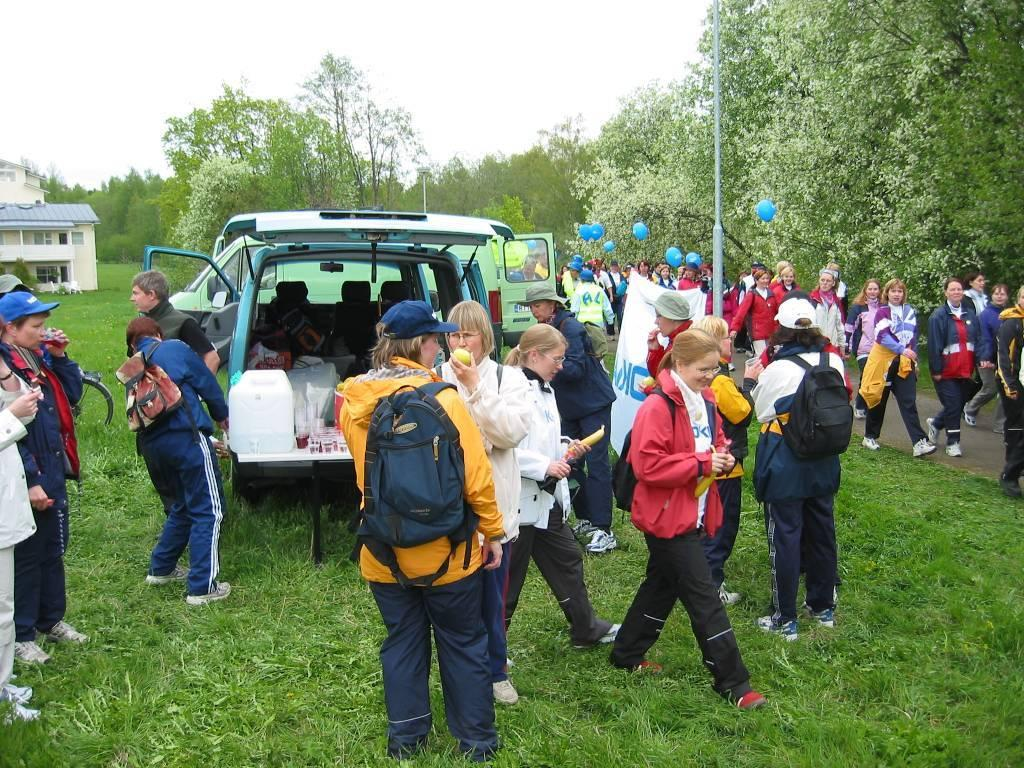What type of motor vehicle is on the ground in the image? The image does not specify the type of motor vehicle, but there is a motor vehicle on the ground. What is the person standing on in the image? The person is standing on the ground in the image. What can be seen on the ground in the image? There is a road in the image. What is visible in the background of the image? There are poles, buildings, trees, and the sky visible in the background of the image. Can you hear the person crying in the image? There is no indication of sound or crying in the image, as it is a still photograph. What type of ocean can be seen in the background of the image? There is no ocean present in the image; it features a road, buildings, trees, and the sky in the background. 